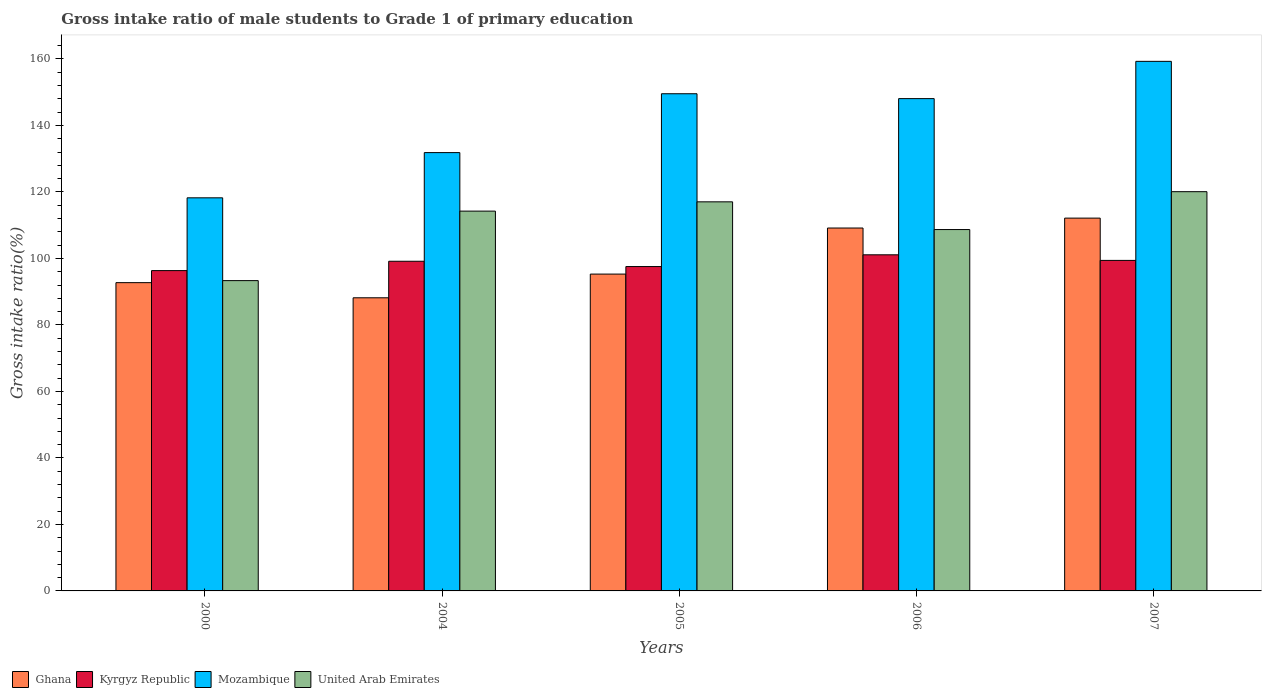How many different coloured bars are there?
Your response must be concise. 4. How many bars are there on the 2nd tick from the right?
Offer a very short reply. 4. What is the label of the 4th group of bars from the left?
Provide a short and direct response. 2006. In how many cases, is the number of bars for a given year not equal to the number of legend labels?
Provide a succinct answer. 0. What is the gross intake ratio in Mozambique in 2004?
Make the answer very short. 131.84. Across all years, what is the maximum gross intake ratio in Ghana?
Your response must be concise. 112.13. Across all years, what is the minimum gross intake ratio in Mozambique?
Offer a terse response. 118.24. In which year was the gross intake ratio in Mozambique maximum?
Keep it short and to the point. 2007. What is the total gross intake ratio in Ghana in the graph?
Provide a succinct answer. 497.49. What is the difference between the gross intake ratio in Mozambique in 2005 and that in 2007?
Make the answer very short. -9.74. What is the difference between the gross intake ratio in United Arab Emirates in 2000 and the gross intake ratio in Mozambique in 2006?
Provide a short and direct response. -54.75. What is the average gross intake ratio in Mozambique per year?
Ensure brevity in your answer.  141.4. In the year 2005, what is the difference between the gross intake ratio in Kyrgyz Republic and gross intake ratio in Ghana?
Your answer should be very brief. 2.26. In how many years, is the gross intake ratio in United Arab Emirates greater than 64 %?
Give a very brief answer. 5. What is the ratio of the gross intake ratio in Mozambique in 2005 to that in 2007?
Provide a succinct answer. 0.94. Is the gross intake ratio in Mozambique in 2006 less than that in 2007?
Give a very brief answer. Yes. What is the difference between the highest and the second highest gross intake ratio in Kyrgyz Republic?
Your answer should be compact. 1.68. What is the difference between the highest and the lowest gross intake ratio in Ghana?
Your response must be concise. 23.96. In how many years, is the gross intake ratio in United Arab Emirates greater than the average gross intake ratio in United Arab Emirates taken over all years?
Make the answer very short. 3. Is it the case that in every year, the sum of the gross intake ratio in Ghana and gross intake ratio in Mozambique is greater than the sum of gross intake ratio in Kyrgyz Republic and gross intake ratio in United Arab Emirates?
Offer a very short reply. Yes. What does the 4th bar from the left in 2004 represents?
Offer a terse response. United Arab Emirates. What does the 1st bar from the right in 2004 represents?
Your response must be concise. United Arab Emirates. How many bars are there?
Your answer should be compact. 20. How many years are there in the graph?
Keep it short and to the point. 5. Are the values on the major ticks of Y-axis written in scientific E-notation?
Provide a succinct answer. No. Does the graph contain grids?
Provide a succinct answer. No. Where does the legend appear in the graph?
Offer a very short reply. Bottom left. How are the legend labels stacked?
Ensure brevity in your answer.  Horizontal. What is the title of the graph?
Your answer should be very brief. Gross intake ratio of male students to Grade 1 of primary education. Does "French Polynesia" appear as one of the legend labels in the graph?
Your response must be concise. No. What is the label or title of the Y-axis?
Offer a terse response. Gross intake ratio(%). What is the Gross intake ratio(%) in Ghana in 2000?
Give a very brief answer. 92.73. What is the Gross intake ratio(%) of Kyrgyz Republic in 2000?
Keep it short and to the point. 96.35. What is the Gross intake ratio(%) of Mozambique in 2000?
Provide a short and direct response. 118.24. What is the Gross intake ratio(%) in United Arab Emirates in 2000?
Offer a terse response. 93.33. What is the Gross intake ratio(%) of Ghana in 2004?
Ensure brevity in your answer.  88.17. What is the Gross intake ratio(%) in Kyrgyz Republic in 2004?
Provide a short and direct response. 99.16. What is the Gross intake ratio(%) of Mozambique in 2004?
Provide a short and direct response. 131.84. What is the Gross intake ratio(%) in United Arab Emirates in 2004?
Ensure brevity in your answer.  114.24. What is the Gross intake ratio(%) of Ghana in 2005?
Provide a succinct answer. 95.3. What is the Gross intake ratio(%) of Kyrgyz Republic in 2005?
Offer a terse response. 97.57. What is the Gross intake ratio(%) of Mozambique in 2005?
Offer a very short reply. 149.54. What is the Gross intake ratio(%) of United Arab Emirates in 2005?
Offer a terse response. 117.03. What is the Gross intake ratio(%) in Ghana in 2006?
Make the answer very short. 109.15. What is the Gross intake ratio(%) in Kyrgyz Republic in 2006?
Your answer should be compact. 101.1. What is the Gross intake ratio(%) of Mozambique in 2006?
Keep it short and to the point. 148.08. What is the Gross intake ratio(%) in United Arab Emirates in 2006?
Provide a short and direct response. 108.7. What is the Gross intake ratio(%) of Ghana in 2007?
Provide a short and direct response. 112.13. What is the Gross intake ratio(%) in Kyrgyz Republic in 2007?
Provide a short and direct response. 99.42. What is the Gross intake ratio(%) of Mozambique in 2007?
Provide a succinct answer. 159.29. What is the Gross intake ratio(%) of United Arab Emirates in 2007?
Your answer should be compact. 120.09. Across all years, what is the maximum Gross intake ratio(%) of Ghana?
Your answer should be very brief. 112.13. Across all years, what is the maximum Gross intake ratio(%) in Kyrgyz Republic?
Provide a succinct answer. 101.1. Across all years, what is the maximum Gross intake ratio(%) in Mozambique?
Provide a succinct answer. 159.29. Across all years, what is the maximum Gross intake ratio(%) in United Arab Emirates?
Ensure brevity in your answer.  120.09. Across all years, what is the minimum Gross intake ratio(%) of Ghana?
Offer a very short reply. 88.17. Across all years, what is the minimum Gross intake ratio(%) of Kyrgyz Republic?
Your response must be concise. 96.35. Across all years, what is the minimum Gross intake ratio(%) of Mozambique?
Keep it short and to the point. 118.24. Across all years, what is the minimum Gross intake ratio(%) in United Arab Emirates?
Your answer should be very brief. 93.33. What is the total Gross intake ratio(%) of Ghana in the graph?
Make the answer very short. 497.49. What is the total Gross intake ratio(%) of Kyrgyz Republic in the graph?
Offer a very short reply. 493.58. What is the total Gross intake ratio(%) of Mozambique in the graph?
Make the answer very short. 706.98. What is the total Gross intake ratio(%) of United Arab Emirates in the graph?
Make the answer very short. 553.39. What is the difference between the Gross intake ratio(%) in Ghana in 2000 and that in 2004?
Ensure brevity in your answer.  4.55. What is the difference between the Gross intake ratio(%) of Kyrgyz Republic in 2000 and that in 2004?
Your response must be concise. -2.81. What is the difference between the Gross intake ratio(%) of Mozambique in 2000 and that in 2004?
Your answer should be very brief. -13.6. What is the difference between the Gross intake ratio(%) in United Arab Emirates in 2000 and that in 2004?
Your answer should be very brief. -20.9. What is the difference between the Gross intake ratio(%) in Ghana in 2000 and that in 2005?
Offer a terse response. -2.58. What is the difference between the Gross intake ratio(%) in Kyrgyz Republic in 2000 and that in 2005?
Offer a very short reply. -1.22. What is the difference between the Gross intake ratio(%) of Mozambique in 2000 and that in 2005?
Keep it short and to the point. -31.31. What is the difference between the Gross intake ratio(%) of United Arab Emirates in 2000 and that in 2005?
Make the answer very short. -23.7. What is the difference between the Gross intake ratio(%) in Ghana in 2000 and that in 2006?
Offer a terse response. -16.43. What is the difference between the Gross intake ratio(%) of Kyrgyz Republic in 2000 and that in 2006?
Provide a short and direct response. -4.75. What is the difference between the Gross intake ratio(%) in Mozambique in 2000 and that in 2006?
Your answer should be compact. -29.84. What is the difference between the Gross intake ratio(%) of United Arab Emirates in 2000 and that in 2006?
Give a very brief answer. -15.36. What is the difference between the Gross intake ratio(%) in Ghana in 2000 and that in 2007?
Offer a terse response. -19.41. What is the difference between the Gross intake ratio(%) of Kyrgyz Republic in 2000 and that in 2007?
Your answer should be compact. -3.07. What is the difference between the Gross intake ratio(%) of Mozambique in 2000 and that in 2007?
Make the answer very short. -41.05. What is the difference between the Gross intake ratio(%) of United Arab Emirates in 2000 and that in 2007?
Give a very brief answer. -26.75. What is the difference between the Gross intake ratio(%) of Ghana in 2004 and that in 2005?
Offer a terse response. -7.13. What is the difference between the Gross intake ratio(%) in Kyrgyz Republic in 2004 and that in 2005?
Offer a terse response. 1.59. What is the difference between the Gross intake ratio(%) of Mozambique in 2004 and that in 2005?
Provide a succinct answer. -17.7. What is the difference between the Gross intake ratio(%) in United Arab Emirates in 2004 and that in 2005?
Give a very brief answer. -2.79. What is the difference between the Gross intake ratio(%) of Ghana in 2004 and that in 2006?
Your answer should be very brief. -20.98. What is the difference between the Gross intake ratio(%) in Kyrgyz Republic in 2004 and that in 2006?
Offer a very short reply. -1.94. What is the difference between the Gross intake ratio(%) of Mozambique in 2004 and that in 2006?
Offer a very short reply. -16.24. What is the difference between the Gross intake ratio(%) of United Arab Emirates in 2004 and that in 2006?
Provide a short and direct response. 5.54. What is the difference between the Gross intake ratio(%) of Ghana in 2004 and that in 2007?
Provide a succinct answer. -23.96. What is the difference between the Gross intake ratio(%) in Kyrgyz Republic in 2004 and that in 2007?
Provide a short and direct response. -0.26. What is the difference between the Gross intake ratio(%) of Mozambique in 2004 and that in 2007?
Your response must be concise. -27.45. What is the difference between the Gross intake ratio(%) in United Arab Emirates in 2004 and that in 2007?
Ensure brevity in your answer.  -5.85. What is the difference between the Gross intake ratio(%) in Ghana in 2005 and that in 2006?
Your response must be concise. -13.85. What is the difference between the Gross intake ratio(%) in Kyrgyz Republic in 2005 and that in 2006?
Your answer should be compact. -3.53. What is the difference between the Gross intake ratio(%) in Mozambique in 2005 and that in 2006?
Give a very brief answer. 1.46. What is the difference between the Gross intake ratio(%) of United Arab Emirates in 2005 and that in 2006?
Offer a terse response. 8.34. What is the difference between the Gross intake ratio(%) in Ghana in 2005 and that in 2007?
Your response must be concise. -16.83. What is the difference between the Gross intake ratio(%) in Kyrgyz Republic in 2005 and that in 2007?
Offer a terse response. -1.85. What is the difference between the Gross intake ratio(%) in Mozambique in 2005 and that in 2007?
Your answer should be very brief. -9.74. What is the difference between the Gross intake ratio(%) of United Arab Emirates in 2005 and that in 2007?
Ensure brevity in your answer.  -3.06. What is the difference between the Gross intake ratio(%) in Ghana in 2006 and that in 2007?
Provide a short and direct response. -2.98. What is the difference between the Gross intake ratio(%) in Kyrgyz Republic in 2006 and that in 2007?
Your answer should be compact. 1.68. What is the difference between the Gross intake ratio(%) of Mozambique in 2006 and that in 2007?
Your answer should be very brief. -11.21. What is the difference between the Gross intake ratio(%) of United Arab Emirates in 2006 and that in 2007?
Your answer should be compact. -11.39. What is the difference between the Gross intake ratio(%) in Ghana in 2000 and the Gross intake ratio(%) in Kyrgyz Republic in 2004?
Your answer should be very brief. -6.43. What is the difference between the Gross intake ratio(%) in Ghana in 2000 and the Gross intake ratio(%) in Mozambique in 2004?
Your response must be concise. -39.11. What is the difference between the Gross intake ratio(%) of Ghana in 2000 and the Gross intake ratio(%) of United Arab Emirates in 2004?
Your answer should be compact. -21.51. What is the difference between the Gross intake ratio(%) in Kyrgyz Republic in 2000 and the Gross intake ratio(%) in Mozambique in 2004?
Provide a short and direct response. -35.49. What is the difference between the Gross intake ratio(%) of Kyrgyz Republic in 2000 and the Gross intake ratio(%) of United Arab Emirates in 2004?
Offer a very short reply. -17.89. What is the difference between the Gross intake ratio(%) of Mozambique in 2000 and the Gross intake ratio(%) of United Arab Emirates in 2004?
Keep it short and to the point. 4. What is the difference between the Gross intake ratio(%) of Ghana in 2000 and the Gross intake ratio(%) of Kyrgyz Republic in 2005?
Offer a terse response. -4.84. What is the difference between the Gross intake ratio(%) in Ghana in 2000 and the Gross intake ratio(%) in Mozambique in 2005?
Your answer should be very brief. -56.82. What is the difference between the Gross intake ratio(%) of Ghana in 2000 and the Gross intake ratio(%) of United Arab Emirates in 2005?
Provide a short and direct response. -24.31. What is the difference between the Gross intake ratio(%) in Kyrgyz Republic in 2000 and the Gross intake ratio(%) in Mozambique in 2005?
Your response must be concise. -53.2. What is the difference between the Gross intake ratio(%) of Kyrgyz Republic in 2000 and the Gross intake ratio(%) of United Arab Emirates in 2005?
Offer a terse response. -20.69. What is the difference between the Gross intake ratio(%) of Mozambique in 2000 and the Gross intake ratio(%) of United Arab Emirates in 2005?
Provide a short and direct response. 1.2. What is the difference between the Gross intake ratio(%) in Ghana in 2000 and the Gross intake ratio(%) in Kyrgyz Republic in 2006?
Give a very brief answer. -8.37. What is the difference between the Gross intake ratio(%) in Ghana in 2000 and the Gross intake ratio(%) in Mozambique in 2006?
Keep it short and to the point. -55.35. What is the difference between the Gross intake ratio(%) in Ghana in 2000 and the Gross intake ratio(%) in United Arab Emirates in 2006?
Provide a succinct answer. -15.97. What is the difference between the Gross intake ratio(%) of Kyrgyz Republic in 2000 and the Gross intake ratio(%) of Mozambique in 2006?
Offer a terse response. -51.73. What is the difference between the Gross intake ratio(%) in Kyrgyz Republic in 2000 and the Gross intake ratio(%) in United Arab Emirates in 2006?
Your answer should be compact. -12.35. What is the difference between the Gross intake ratio(%) of Mozambique in 2000 and the Gross intake ratio(%) of United Arab Emirates in 2006?
Your response must be concise. 9.54. What is the difference between the Gross intake ratio(%) of Ghana in 2000 and the Gross intake ratio(%) of Kyrgyz Republic in 2007?
Your answer should be very brief. -6.69. What is the difference between the Gross intake ratio(%) in Ghana in 2000 and the Gross intake ratio(%) in Mozambique in 2007?
Provide a succinct answer. -66.56. What is the difference between the Gross intake ratio(%) of Ghana in 2000 and the Gross intake ratio(%) of United Arab Emirates in 2007?
Give a very brief answer. -27.36. What is the difference between the Gross intake ratio(%) of Kyrgyz Republic in 2000 and the Gross intake ratio(%) of Mozambique in 2007?
Give a very brief answer. -62.94. What is the difference between the Gross intake ratio(%) in Kyrgyz Republic in 2000 and the Gross intake ratio(%) in United Arab Emirates in 2007?
Your response must be concise. -23.74. What is the difference between the Gross intake ratio(%) of Mozambique in 2000 and the Gross intake ratio(%) of United Arab Emirates in 2007?
Give a very brief answer. -1.85. What is the difference between the Gross intake ratio(%) in Ghana in 2004 and the Gross intake ratio(%) in Kyrgyz Republic in 2005?
Your answer should be compact. -9.39. What is the difference between the Gross intake ratio(%) of Ghana in 2004 and the Gross intake ratio(%) of Mozambique in 2005?
Offer a very short reply. -61.37. What is the difference between the Gross intake ratio(%) of Ghana in 2004 and the Gross intake ratio(%) of United Arab Emirates in 2005?
Make the answer very short. -28.86. What is the difference between the Gross intake ratio(%) in Kyrgyz Republic in 2004 and the Gross intake ratio(%) in Mozambique in 2005?
Your answer should be very brief. -50.38. What is the difference between the Gross intake ratio(%) in Kyrgyz Republic in 2004 and the Gross intake ratio(%) in United Arab Emirates in 2005?
Your answer should be very brief. -17.87. What is the difference between the Gross intake ratio(%) of Mozambique in 2004 and the Gross intake ratio(%) of United Arab Emirates in 2005?
Keep it short and to the point. 14.81. What is the difference between the Gross intake ratio(%) in Ghana in 2004 and the Gross intake ratio(%) in Kyrgyz Republic in 2006?
Make the answer very short. -12.93. What is the difference between the Gross intake ratio(%) of Ghana in 2004 and the Gross intake ratio(%) of Mozambique in 2006?
Provide a short and direct response. -59.91. What is the difference between the Gross intake ratio(%) of Ghana in 2004 and the Gross intake ratio(%) of United Arab Emirates in 2006?
Ensure brevity in your answer.  -20.52. What is the difference between the Gross intake ratio(%) in Kyrgyz Republic in 2004 and the Gross intake ratio(%) in Mozambique in 2006?
Offer a very short reply. -48.92. What is the difference between the Gross intake ratio(%) in Kyrgyz Republic in 2004 and the Gross intake ratio(%) in United Arab Emirates in 2006?
Offer a terse response. -9.54. What is the difference between the Gross intake ratio(%) of Mozambique in 2004 and the Gross intake ratio(%) of United Arab Emirates in 2006?
Your answer should be compact. 23.14. What is the difference between the Gross intake ratio(%) of Ghana in 2004 and the Gross intake ratio(%) of Kyrgyz Republic in 2007?
Offer a very short reply. -11.25. What is the difference between the Gross intake ratio(%) in Ghana in 2004 and the Gross intake ratio(%) in Mozambique in 2007?
Ensure brevity in your answer.  -71.12. What is the difference between the Gross intake ratio(%) of Ghana in 2004 and the Gross intake ratio(%) of United Arab Emirates in 2007?
Your answer should be very brief. -31.92. What is the difference between the Gross intake ratio(%) in Kyrgyz Republic in 2004 and the Gross intake ratio(%) in Mozambique in 2007?
Ensure brevity in your answer.  -60.13. What is the difference between the Gross intake ratio(%) in Kyrgyz Republic in 2004 and the Gross intake ratio(%) in United Arab Emirates in 2007?
Provide a short and direct response. -20.93. What is the difference between the Gross intake ratio(%) of Mozambique in 2004 and the Gross intake ratio(%) of United Arab Emirates in 2007?
Provide a succinct answer. 11.75. What is the difference between the Gross intake ratio(%) of Ghana in 2005 and the Gross intake ratio(%) of Kyrgyz Republic in 2006?
Make the answer very short. -5.8. What is the difference between the Gross intake ratio(%) in Ghana in 2005 and the Gross intake ratio(%) in Mozambique in 2006?
Offer a very short reply. -52.78. What is the difference between the Gross intake ratio(%) of Ghana in 2005 and the Gross intake ratio(%) of United Arab Emirates in 2006?
Your answer should be compact. -13.39. What is the difference between the Gross intake ratio(%) in Kyrgyz Republic in 2005 and the Gross intake ratio(%) in Mozambique in 2006?
Ensure brevity in your answer.  -50.51. What is the difference between the Gross intake ratio(%) in Kyrgyz Republic in 2005 and the Gross intake ratio(%) in United Arab Emirates in 2006?
Your response must be concise. -11.13. What is the difference between the Gross intake ratio(%) of Mozambique in 2005 and the Gross intake ratio(%) of United Arab Emirates in 2006?
Your answer should be very brief. 40.85. What is the difference between the Gross intake ratio(%) in Ghana in 2005 and the Gross intake ratio(%) in Kyrgyz Republic in 2007?
Provide a short and direct response. -4.12. What is the difference between the Gross intake ratio(%) of Ghana in 2005 and the Gross intake ratio(%) of Mozambique in 2007?
Keep it short and to the point. -63.98. What is the difference between the Gross intake ratio(%) of Ghana in 2005 and the Gross intake ratio(%) of United Arab Emirates in 2007?
Give a very brief answer. -24.79. What is the difference between the Gross intake ratio(%) in Kyrgyz Republic in 2005 and the Gross intake ratio(%) in Mozambique in 2007?
Your answer should be very brief. -61.72. What is the difference between the Gross intake ratio(%) of Kyrgyz Republic in 2005 and the Gross intake ratio(%) of United Arab Emirates in 2007?
Give a very brief answer. -22.52. What is the difference between the Gross intake ratio(%) of Mozambique in 2005 and the Gross intake ratio(%) of United Arab Emirates in 2007?
Give a very brief answer. 29.46. What is the difference between the Gross intake ratio(%) of Ghana in 2006 and the Gross intake ratio(%) of Kyrgyz Republic in 2007?
Offer a terse response. 9.74. What is the difference between the Gross intake ratio(%) in Ghana in 2006 and the Gross intake ratio(%) in Mozambique in 2007?
Your response must be concise. -50.13. What is the difference between the Gross intake ratio(%) in Ghana in 2006 and the Gross intake ratio(%) in United Arab Emirates in 2007?
Your answer should be very brief. -10.93. What is the difference between the Gross intake ratio(%) of Kyrgyz Republic in 2006 and the Gross intake ratio(%) of Mozambique in 2007?
Provide a short and direct response. -58.19. What is the difference between the Gross intake ratio(%) in Kyrgyz Republic in 2006 and the Gross intake ratio(%) in United Arab Emirates in 2007?
Make the answer very short. -18.99. What is the difference between the Gross intake ratio(%) of Mozambique in 2006 and the Gross intake ratio(%) of United Arab Emirates in 2007?
Your answer should be compact. 27.99. What is the average Gross intake ratio(%) of Ghana per year?
Your answer should be very brief. 99.5. What is the average Gross intake ratio(%) of Kyrgyz Republic per year?
Make the answer very short. 98.72. What is the average Gross intake ratio(%) of Mozambique per year?
Give a very brief answer. 141.4. What is the average Gross intake ratio(%) of United Arab Emirates per year?
Provide a short and direct response. 110.68. In the year 2000, what is the difference between the Gross intake ratio(%) of Ghana and Gross intake ratio(%) of Kyrgyz Republic?
Ensure brevity in your answer.  -3.62. In the year 2000, what is the difference between the Gross intake ratio(%) of Ghana and Gross intake ratio(%) of Mozambique?
Provide a succinct answer. -25.51. In the year 2000, what is the difference between the Gross intake ratio(%) in Ghana and Gross intake ratio(%) in United Arab Emirates?
Your response must be concise. -0.61. In the year 2000, what is the difference between the Gross intake ratio(%) of Kyrgyz Republic and Gross intake ratio(%) of Mozambique?
Offer a very short reply. -21.89. In the year 2000, what is the difference between the Gross intake ratio(%) in Kyrgyz Republic and Gross intake ratio(%) in United Arab Emirates?
Make the answer very short. 3.01. In the year 2000, what is the difference between the Gross intake ratio(%) in Mozambique and Gross intake ratio(%) in United Arab Emirates?
Your answer should be compact. 24.9. In the year 2004, what is the difference between the Gross intake ratio(%) in Ghana and Gross intake ratio(%) in Kyrgyz Republic?
Make the answer very short. -10.99. In the year 2004, what is the difference between the Gross intake ratio(%) of Ghana and Gross intake ratio(%) of Mozambique?
Offer a terse response. -43.67. In the year 2004, what is the difference between the Gross intake ratio(%) in Ghana and Gross intake ratio(%) in United Arab Emirates?
Provide a short and direct response. -26.07. In the year 2004, what is the difference between the Gross intake ratio(%) of Kyrgyz Republic and Gross intake ratio(%) of Mozambique?
Your response must be concise. -32.68. In the year 2004, what is the difference between the Gross intake ratio(%) of Kyrgyz Republic and Gross intake ratio(%) of United Arab Emirates?
Your response must be concise. -15.08. In the year 2004, what is the difference between the Gross intake ratio(%) of Mozambique and Gross intake ratio(%) of United Arab Emirates?
Keep it short and to the point. 17.6. In the year 2005, what is the difference between the Gross intake ratio(%) of Ghana and Gross intake ratio(%) of Kyrgyz Republic?
Your response must be concise. -2.26. In the year 2005, what is the difference between the Gross intake ratio(%) of Ghana and Gross intake ratio(%) of Mozambique?
Ensure brevity in your answer.  -54.24. In the year 2005, what is the difference between the Gross intake ratio(%) of Ghana and Gross intake ratio(%) of United Arab Emirates?
Offer a very short reply. -21.73. In the year 2005, what is the difference between the Gross intake ratio(%) in Kyrgyz Republic and Gross intake ratio(%) in Mozambique?
Give a very brief answer. -51.98. In the year 2005, what is the difference between the Gross intake ratio(%) in Kyrgyz Republic and Gross intake ratio(%) in United Arab Emirates?
Make the answer very short. -19.47. In the year 2005, what is the difference between the Gross intake ratio(%) in Mozambique and Gross intake ratio(%) in United Arab Emirates?
Offer a terse response. 32.51. In the year 2006, what is the difference between the Gross intake ratio(%) of Ghana and Gross intake ratio(%) of Kyrgyz Republic?
Provide a succinct answer. 8.06. In the year 2006, what is the difference between the Gross intake ratio(%) of Ghana and Gross intake ratio(%) of Mozambique?
Ensure brevity in your answer.  -38.92. In the year 2006, what is the difference between the Gross intake ratio(%) of Ghana and Gross intake ratio(%) of United Arab Emirates?
Give a very brief answer. 0.46. In the year 2006, what is the difference between the Gross intake ratio(%) of Kyrgyz Republic and Gross intake ratio(%) of Mozambique?
Offer a terse response. -46.98. In the year 2006, what is the difference between the Gross intake ratio(%) in Kyrgyz Republic and Gross intake ratio(%) in United Arab Emirates?
Keep it short and to the point. -7.6. In the year 2006, what is the difference between the Gross intake ratio(%) of Mozambique and Gross intake ratio(%) of United Arab Emirates?
Give a very brief answer. 39.38. In the year 2007, what is the difference between the Gross intake ratio(%) of Ghana and Gross intake ratio(%) of Kyrgyz Republic?
Give a very brief answer. 12.72. In the year 2007, what is the difference between the Gross intake ratio(%) in Ghana and Gross intake ratio(%) in Mozambique?
Your response must be concise. -47.15. In the year 2007, what is the difference between the Gross intake ratio(%) of Ghana and Gross intake ratio(%) of United Arab Emirates?
Your answer should be very brief. -7.95. In the year 2007, what is the difference between the Gross intake ratio(%) in Kyrgyz Republic and Gross intake ratio(%) in Mozambique?
Ensure brevity in your answer.  -59.87. In the year 2007, what is the difference between the Gross intake ratio(%) of Kyrgyz Republic and Gross intake ratio(%) of United Arab Emirates?
Ensure brevity in your answer.  -20.67. In the year 2007, what is the difference between the Gross intake ratio(%) in Mozambique and Gross intake ratio(%) in United Arab Emirates?
Offer a very short reply. 39.2. What is the ratio of the Gross intake ratio(%) of Ghana in 2000 to that in 2004?
Ensure brevity in your answer.  1.05. What is the ratio of the Gross intake ratio(%) of Kyrgyz Republic in 2000 to that in 2004?
Offer a very short reply. 0.97. What is the ratio of the Gross intake ratio(%) of Mozambique in 2000 to that in 2004?
Your answer should be compact. 0.9. What is the ratio of the Gross intake ratio(%) of United Arab Emirates in 2000 to that in 2004?
Your answer should be compact. 0.82. What is the ratio of the Gross intake ratio(%) in Kyrgyz Republic in 2000 to that in 2005?
Your response must be concise. 0.99. What is the ratio of the Gross intake ratio(%) of Mozambique in 2000 to that in 2005?
Your answer should be very brief. 0.79. What is the ratio of the Gross intake ratio(%) in United Arab Emirates in 2000 to that in 2005?
Your answer should be compact. 0.8. What is the ratio of the Gross intake ratio(%) of Ghana in 2000 to that in 2006?
Your answer should be compact. 0.85. What is the ratio of the Gross intake ratio(%) in Kyrgyz Republic in 2000 to that in 2006?
Keep it short and to the point. 0.95. What is the ratio of the Gross intake ratio(%) of Mozambique in 2000 to that in 2006?
Offer a terse response. 0.8. What is the ratio of the Gross intake ratio(%) in United Arab Emirates in 2000 to that in 2006?
Your response must be concise. 0.86. What is the ratio of the Gross intake ratio(%) in Ghana in 2000 to that in 2007?
Your response must be concise. 0.83. What is the ratio of the Gross intake ratio(%) of Kyrgyz Republic in 2000 to that in 2007?
Your answer should be compact. 0.97. What is the ratio of the Gross intake ratio(%) of Mozambique in 2000 to that in 2007?
Provide a succinct answer. 0.74. What is the ratio of the Gross intake ratio(%) of United Arab Emirates in 2000 to that in 2007?
Provide a short and direct response. 0.78. What is the ratio of the Gross intake ratio(%) in Ghana in 2004 to that in 2005?
Your response must be concise. 0.93. What is the ratio of the Gross intake ratio(%) in Kyrgyz Republic in 2004 to that in 2005?
Your answer should be compact. 1.02. What is the ratio of the Gross intake ratio(%) in Mozambique in 2004 to that in 2005?
Offer a terse response. 0.88. What is the ratio of the Gross intake ratio(%) in United Arab Emirates in 2004 to that in 2005?
Your answer should be very brief. 0.98. What is the ratio of the Gross intake ratio(%) in Ghana in 2004 to that in 2006?
Your answer should be very brief. 0.81. What is the ratio of the Gross intake ratio(%) in Kyrgyz Republic in 2004 to that in 2006?
Your response must be concise. 0.98. What is the ratio of the Gross intake ratio(%) in Mozambique in 2004 to that in 2006?
Make the answer very short. 0.89. What is the ratio of the Gross intake ratio(%) of United Arab Emirates in 2004 to that in 2006?
Ensure brevity in your answer.  1.05. What is the ratio of the Gross intake ratio(%) in Ghana in 2004 to that in 2007?
Offer a very short reply. 0.79. What is the ratio of the Gross intake ratio(%) in Kyrgyz Republic in 2004 to that in 2007?
Your response must be concise. 1. What is the ratio of the Gross intake ratio(%) of Mozambique in 2004 to that in 2007?
Ensure brevity in your answer.  0.83. What is the ratio of the Gross intake ratio(%) in United Arab Emirates in 2004 to that in 2007?
Make the answer very short. 0.95. What is the ratio of the Gross intake ratio(%) of Ghana in 2005 to that in 2006?
Offer a terse response. 0.87. What is the ratio of the Gross intake ratio(%) in Kyrgyz Republic in 2005 to that in 2006?
Offer a very short reply. 0.97. What is the ratio of the Gross intake ratio(%) in Mozambique in 2005 to that in 2006?
Your answer should be very brief. 1.01. What is the ratio of the Gross intake ratio(%) in United Arab Emirates in 2005 to that in 2006?
Your answer should be very brief. 1.08. What is the ratio of the Gross intake ratio(%) in Ghana in 2005 to that in 2007?
Your answer should be compact. 0.85. What is the ratio of the Gross intake ratio(%) of Kyrgyz Republic in 2005 to that in 2007?
Ensure brevity in your answer.  0.98. What is the ratio of the Gross intake ratio(%) in Mozambique in 2005 to that in 2007?
Offer a very short reply. 0.94. What is the ratio of the Gross intake ratio(%) of United Arab Emirates in 2005 to that in 2007?
Your answer should be compact. 0.97. What is the ratio of the Gross intake ratio(%) in Ghana in 2006 to that in 2007?
Your answer should be compact. 0.97. What is the ratio of the Gross intake ratio(%) of Kyrgyz Republic in 2006 to that in 2007?
Ensure brevity in your answer.  1.02. What is the ratio of the Gross intake ratio(%) in Mozambique in 2006 to that in 2007?
Make the answer very short. 0.93. What is the ratio of the Gross intake ratio(%) in United Arab Emirates in 2006 to that in 2007?
Give a very brief answer. 0.91. What is the difference between the highest and the second highest Gross intake ratio(%) in Ghana?
Offer a terse response. 2.98. What is the difference between the highest and the second highest Gross intake ratio(%) in Kyrgyz Republic?
Give a very brief answer. 1.68. What is the difference between the highest and the second highest Gross intake ratio(%) of Mozambique?
Your answer should be compact. 9.74. What is the difference between the highest and the second highest Gross intake ratio(%) of United Arab Emirates?
Offer a terse response. 3.06. What is the difference between the highest and the lowest Gross intake ratio(%) in Ghana?
Provide a short and direct response. 23.96. What is the difference between the highest and the lowest Gross intake ratio(%) of Kyrgyz Republic?
Your response must be concise. 4.75. What is the difference between the highest and the lowest Gross intake ratio(%) of Mozambique?
Ensure brevity in your answer.  41.05. What is the difference between the highest and the lowest Gross intake ratio(%) in United Arab Emirates?
Your answer should be compact. 26.75. 